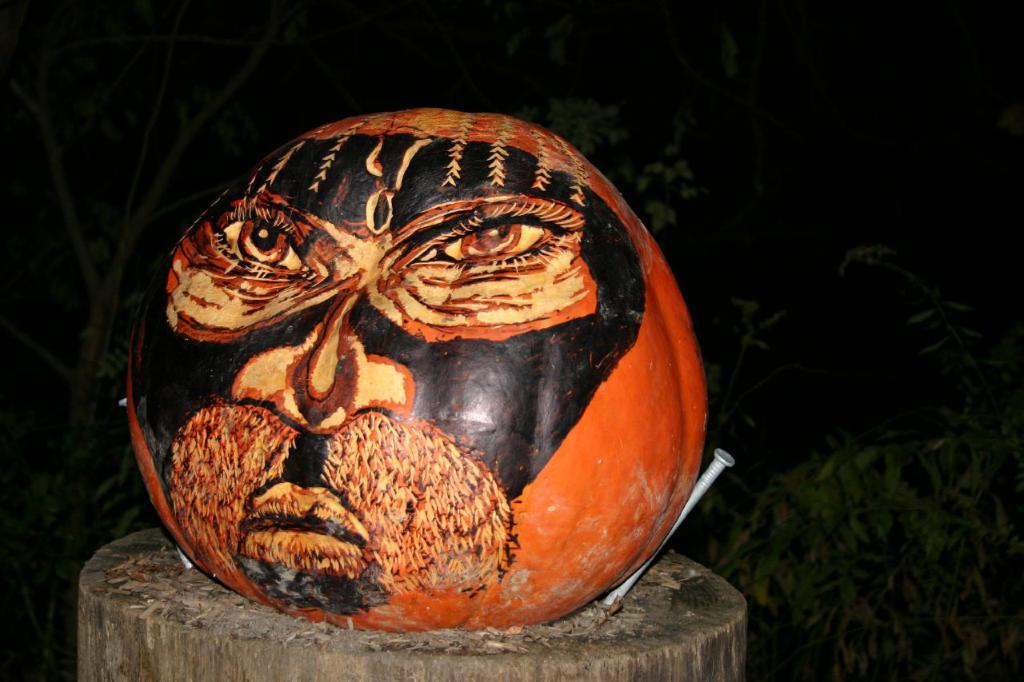What is the main subject of the image? The main subject of the image is a painting on a pumpkin. Where is the pumpkin placed? The pumpkin is placed on a wooden log. What can be seen in the image that might be used for construction or decoration? Nails are visible in the image. How would you describe the lighting in the image? The background of the image is dark. Can you see a tree or a snake in the image? No, there is no tree or snake present in the image. Is there any indication of an attack happening in the image? No, there is no indication of an attack in the image. 